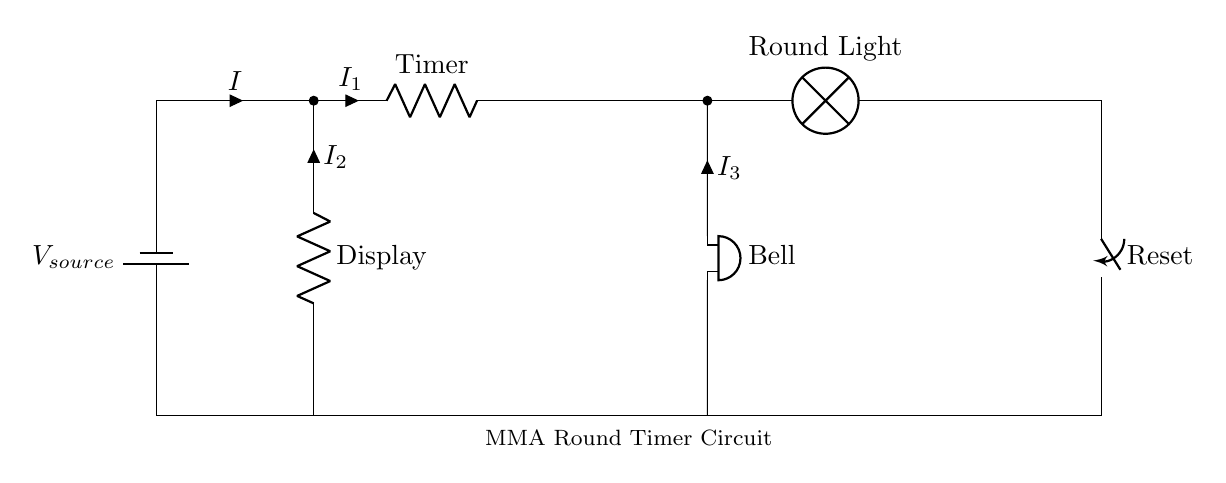What is the primary power source in this circuit? The primary power source is the battery labeled as $V_{source}$, which provides electrical energy for the circuit.
Answer: battery What does the Timer in the circuit do? The Timer component is responsible for measuring and controlling the duration of each round in the MMA match, indicating when a period starts and ends.
Answer: timing How many branches does the circuit have? The circuit has three main branches, each serving a different function: the Timer, the Display, and the Bell.
Answer: three What component is used to signal the end of a round? The component that signals the end of a round is the Bell, which emits a sound when activated.
Answer: Bell What happens when the Reset switch is activated? When the Reset switch is activated, it interrupts the current flow and resets the Timer, preparing it for the next round.
Answer: resets timer 